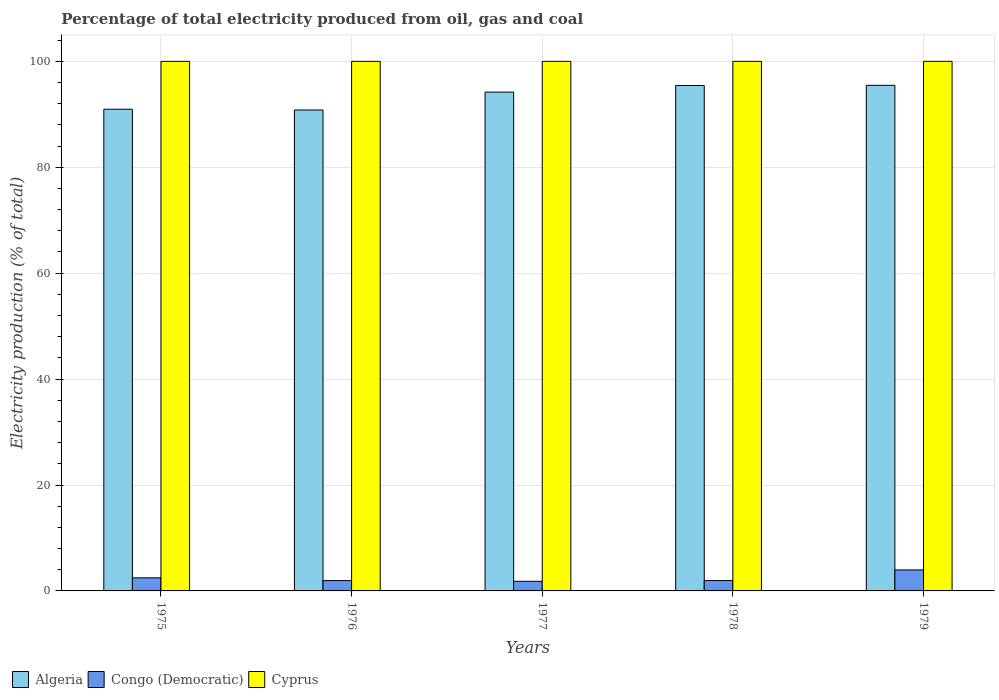How many different coloured bars are there?
Give a very brief answer. 3. How many groups of bars are there?
Provide a short and direct response. 5. Are the number of bars on each tick of the X-axis equal?
Offer a terse response. Yes. How many bars are there on the 1st tick from the right?
Your response must be concise. 3. What is the label of the 2nd group of bars from the left?
Your answer should be compact. 1976. What is the electricity production in in Cyprus in 1976?
Keep it short and to the point. 100. Across all years, what is the maximum electricity production in in Congo (Democratic)?
Provide a short and direct response. 3.97. Across all years, what is the minimum electricity production in in Congo (Democratic)?
Your response must be concise. 1.81. In which year was the electricity production in in Cyprus maximum?
Your response must be concise. 1975. In which year was the electricity production in in Cyprus minimum?
Offer a very short reply. 1975. What is the total electricity production in in Algeria in the graph?
Keep it short and to the point. 466.89. What is the difference between the electricity production in in Congo (Democratic) in 1976 and that in 1978?
Provide a short and direct response. -0. What is the difference between the electricity production in in Congo (Democratic) in 1975 and the electricity production in in Cyprus in 1979?
Offer a terse response. -97.53. What is the average electricity production in in Algeria per year?
Ensure brevity in your answer.  93.38. In the year 1976, what is the difference between the electricity production in in Cyprus and electricity production in in Congo (Democratic)?
Your answer should be compact. 98.04. What is the ratio of the electricity production in in Algeria in 1978 to that in 1979?
Your response must be concise. 1. What is the difference between the highest and the second highest electricity production in in Congo (Democratic)?
Ensure brevity in your answer.  1.49. What is the difference between the highest and the lowest electricity production in in Algeria?
Give a very brief answer. 4.66. Is the sum of the electricity production in in Cyprus in 1975 and 1977 greater than the maximum electricity production in in Algeria across all years?
Your response must be concise. Yes. What does the 3rd bar from the left in 1978 represents?
Ensure brevity in your answer.  Cyprus. What does the 3rd bar from the right in 1976 represents?
Keep it short and to the point. Algeria. Is it the case that in every year, the sum of the electricity production in in Cyprus and electricity production in in Congo (Democratic) is greater than the electricity production in in Algeria?
Your answer should be very brief. Yes. How many bars are there?
Your answer should be compact. 15. Are all the bars in the graph horizontal?
Give a very brief answer. No. Does the graph contain any zero values?
Your answer should be compact. No. Does the graph contain grids?
Provide a short and direct response. Yes. Where does the legend appear in the graph?
Your answer should be compact. Bottom left. How many legend labels are there?
Keep it short and to the point. 3. How are the legend labels stacked?
Offer a very short reply. Horizontal. What is the title of the graph?
Keep it short and to the point. Percentage of total electricity produced from oil, gas and coal. Does "Norway" appear as one of the legend labels in the graph?
Keep it short and to the point. No. What is the label or title of the Y-axis?
Offer a very short reply. Electricity production (% of total). What is the Electricity production (% of total) in Algeria in 1975?
Your answer should be very brief. 90.96. What is the Electricity production (% of total) of Congo (Democratic) in 1975?
Provide a short and direct response. 2.47. What is the Electricity production (% of total) in Cyprus in 1975?
Keep it short and to the point. 100. What is the Electricity production (% of total) of Algeria in 1976?
Ensure brevity in your answer.  90.81. What is the Electricity production (% of total) of Congo (Democratic) in 1976?
Offer a very short reply. 1.96. What is the Electricity production (% of total) of Algeria in 1977?
Your answer should be compact. 94.2. What is the Electricity production (% of total) of Congo (Democratic) in 1977?
Provide a succinct answer. 1.81. What is the Electricity production (% of total) of Algeria in 1978?
Give a very brief answer. 95.44. What is the Electricity production (% of total) in Congo (Democratic) in 1978?
Provide a succinct answer. 1.96. What is the Electricity production (% of total) of Algeria in 1979?
Provide a short and direct response. 95.47. What is the Electricity production (% of total) of Congo (Democratic) in 1979?
Ensure brevity in your answer.  3.97. What is the Electricity production (% of total) in Cyprus in 1979?
Your answer should be compact. 100. Across all years, what is the maximum Electricity production (% of total) of Algeria?
Provide a short and direct response. 95.47. Across all years, what is the maximum Electricity production (% of total) in Congo (Democratic)?
Provide a short and direct response. 3.97. Across all years, what is the maximum Electricity production (% of total) in Cyprus?
Keep it short and to the point. 100. Across all years, what is the minimum Electricity production (% of total) of Algeria?
Give a very brief answer. 90.81. Across all years, what is the minimum Electricity production (% of total) of Congo (Democratic)?
Provide a succinct answer. 1.81. Across all years, what is the minimum Electricity production (% of total) of Cyprus?
Offer a terse response. 100. What is the total Electricity production (% of total) in Algeria in the graph?
Offer a very short reply. 466.89. What is the total Electricity production (% of total) of Congo (Democratic) in the graph?
Your response must be concise. 12.17. What is the total Electricity production (% of total) in Cyprus in the graph?
Your response must be concise. 500. What is the difference between the Electricity production (% of total) of Algeria in 1975 and that in 1976?
Ensure brevity in your answer.  0.15. What is the difference between the Electricity production (% of total) in Congo (Democratic) in 1975 and that in 1976?
Give a very brief answer. 0.52. What is the difference between the Electricity production (% of total) in Algeria in 1975 and that in 1977?
Give a very brief answer. -3.23. What is the difference between the Electricity production (% of total) of Congo (Democratic) in 1975 and that in 1977?
Your answer should be very brief. 0.66. What is the difference between the Electricity production (% of total) of Algeria in 1975 and that in 1978?
Provide a succinct answer. -4.47. What is the difference between the Electricity production (% of total) of Congo (Democratic) in 1975 and that in 1978?
Provide a short and direct response. 0.51. What is the difference between the Electricity production (% of total) in Algeria in 1975 and that in 1979?
Offer a terse response. -4.51. What is the difference between the Electricity production (% of total) of Congo (Democratic) in 1975 and that in 1979?
Offer a very short reply. -1.49. What is the difference between the Electricity production (% of total) of Cyprus in 1975 and that in 1979?
Your answer should be compact. 0. What is the difference between the Electricity production (% of total) in Algeria in 1976 and that in 1977?
Your response must be concise. -3.38. What is the difference between the Electricity production (% of total) in Congo (Democratic) in 1976 and that in 1977?
Your answer should be compact. 0.15. What is the difference between the Electricity production (% of total) in Cyprus in 1976 and that in 1977?
Make the answer very short. 0. What is the difference between the Electricity production (% of total) of Algeria in 1976 and that in 1978?
Give a very brief answer. -4.62. What is the difference between the Electricity production (% of total) in Congo (Democratic) in 1976 and that in 1978?
Your answer should be very brief. -0. What is the difference between the Electricity production (% of total) of Cyprus in 1976 and that in 1978?
Make the answer very short. 0. What is the difference between the Electricity production (% of total) of Algeria in 1976 and that in 1979?
Ensure brevity in your answer.  -4.66. What is the difference between the Electricity production (% of total) in Congo (Democratic) in 1976 and that in 1979?
Keep it short and to the point. -2.01. What is the difference between the Electricity production (% of total) of Algeria in 1977 and that in 1978?
Offer a terse response. -1.24. What is the difference between the Electricity production (% of total) of Congo (Democratic) in 1977 and that in 1978?
Your response must be concise. -0.15. What is the difference between the Electricity production (% of total) in Cyprus in 1977 and that in 1978?
Provide a short and direct response. 0. What is the difference between the Electricity production (% of total) of Algeria in 1977 and that in 1979?
Your answer should be compact. -1.28. What is the difference between the Electricity production (% of total) of Congo (Democratic) in 1977 and that in 1979?
Ensure brevity in your answer.  -2.16. What is the difference between the Electricity production (% of total) in Algeria in 1978 and that in 1979?
Ensure brevity in your answer.  -0.04. What is the difference between the Electricity production (% of total) of Congo (Democratic) in 1978 and that in 1979?
Provide a short and direct response. -2.01. What is the difference between the Electricity production (% of total) in Algeria in 1975 and the Electricity production (% of total) in Congo (Democratic) in 1976?
Offer a very short reply. 89.01. What is the difference between the Electricity production (% of total) in Algeria in 1975 and the Electricity production (% of total) in Cyprus in 1976?
Keep it short and to the point. -9.04. What is the difference between the Electricity production (% of total) of Congo (Democratic) in 1975 and the Electricity production (% of total) of Cyprus in 1976?
Offer a terse response. -97.53. What is the difference between the Electricity production (% of total) of Algeria in 1975 and the Electricity production (% of total) of Congo (Democratic) in 1977?
Keep it short and to the point. 89.15. What is the difference between the Electricity production (% of total) in Algeria in 1975 and the Electricity production (% of total) in Cyprus in 1977?
Offer a very short reply. -9.04. What is the difference between the Electricity production (% of total) in Congo (Democratic) in 1975 and the Electricity production (% of total) in Cyprus in 1977?
Your response must be concise. -97.53. What is the difference between the Electricity production (% of total) of Algeria in 1975 and the Electricity production (% of total) of Congo (Democratic) in 1978?
Offer a terse response. 89. What is the difference between the Electricity production (% of total) of Algeria in 1975 and the Electricity production (% of total) of Cyprus in 1978?
Offer a terse response. -9.04. What is the difference between the Electricity production (% of total) of Congo (Democratic) in 1975 and the Electricity production (% of total) of Cyprus in 1978?
Keep it short and to the point. -97.53. What is the difference between the Electricity production (% of total) in Algeria in 1975 and the Electricity production (% of total) in Congo (Democratic) in 1979?
Keep it short and to the point. 87. What is the difference between the Electricity production (% of total) of Algeria in 1975 and the Electricity production (% of total) of Cyprus in 1979?
Keep it short and to the point. -9.04. What is the difference between the Electricity production (% of total) in Congo (Democratic) in 1975 and the Electricity production (% of total) in Cyprus in 1979?
Your answer should be very brief. -97.53. What is the difference between the Electricity production (% of total) of Algeria in 1976 and the Electricity production (% of total) of Congo (Democratic) in 1977?
Provide a succinct answer. 89. What is the difference between the Electricity production (% of total) in Algeria in 1976 and the Electricity production (% of total) in Cyprus in 1977?
Offer a terse response. -9.19. What is the difference between the Electricity production (% of total) in Congo (Democratic) in 1976 and the Electricity production (% of total) in Cyprus in 1977?
Offer a terse response. -98.04. What is the difference between the Electricity production (% of total) of Algeria in 1976 and the Electricity production (% of total) of Congo (Democratic) in 1978?
Ensure brevity in your answer.  88.85. What is the difference between the Electricity production (% of total) in Algeria in 1976 and the Electricity production (% of total) in Cyprus in 1978?
Make the answer very short. -9.19. What is the difference between the Electricity production (% of total) of Congo (Democratic) in 1976 and the Electricity production (% of total) of Cyprus in 1978?
Offer a very short reply. -98.04. What is the difference between the Electricity production (% of total) in Algeria in 1976 and the Electricity production (% of total) in Congo (Democratic) in 1979?
Ensure brevity in your answer.  86.85. What is the difference between the Electricity production (% of total) in Algeria in 1976 and the Electricity production (% of total) in Cyprus in 1979?
Make the answer very short. -9.19. What is the difference between the Electricity production (% of total) of Congo (Democratic) in 1976 and the Electricity production (% of total) of Cyprus in 1979?
Provide a succinct answer. -98.04. What is the difference between the Electricity production (% of total) of Algeria in 1977 and the Electricity production (% of total) of Congo (Democratic) in 1978?
Keep it short and to the point. 92.24. What is the difference between the Electricity production (% of total) in Algeria in 1977 and the Electricity production (% of total) in Cyprus in 1978?
Your answer should be very brief. -5.8. What is the difference between the Electricity production (% of total) in Congo (Democratic) in 1977 and the Electricity production (% of total) in Cyprus in 1978?
Provide a short and direct response. -98.19. What is the difference between the Electricity production (% of total) of Algeria in 1977 and the Electricity production (% of total) of Congo (Democratic) in 1979?
Offer a terse response. 90.23. What is the difference between the Electricity production (% of total) in Algeria in 1977 and the Electricity production (% of total) in Cyprus in 1979?
Provide a short and direct response. -5.8. What is the difference between the Electricity production (% of total) of Congo (Democratic) in 1977 and the Electricity production (% of total) of Cyprus in 1979?
Provide a succinct answer. -98.19. What is the difference between the Electricity production (% of total) in Algeria in 1978 and the Electricity production (% of total) in Congo (Democratic) in 1979?
Provide a short and direct response. 91.47. What is the difference between the Electricity production (% of total) of Algeria in 1978 and the Electricity production (% of total) of Cyprus in 1979?
Your answer should be very brief. -4.56. What is the difference between the Electricity production (% of total) in Congo (Democratic) in 1978 and the Electricity production (% of total) in Cyprus in 1979?
Your answer should be very brief. -98.04. What is the average Electricity production (% of total) of Algeria per year?
Your answer should be very brief. 93.38. What is the average Electricity production (% of total) in Congo (Democratic) per year?
Give a very brief answer. 2.43. What is the average Electricity production (% of total) in Cyprus per year?
Your response must be concise. 100. In the year 1975, what is the difference between the Electricity production (% of total) in Algeria and Electricity production (% of total) in Congo (Democratic)?
Make the answer very short. 88.49. In the year 1975, what is the difference between the Electricity production (% of total) in Algeria and Electricity production (% of total) in Cyprus?
Provide a succinct answer. -9.04. In the year 1975, what is the difference between the Electricity production (% of total) of Congo (Democratic) and Electricity production (% of total) of Cyprus?
Your answer should be compact. -97.53. In the year 1976, what is the difference between the Electricity production (% of total) in Algeria and Electricity production (% of total) in Congo (Democratic)?
Offer a terse response. 88.86. In the year 1976, what is the difference between the Electricity production (% of total) of Algeria and Electricity production (% of total) of Cyprus?
Provide a succinct answer. -9.19. In the year 1976, what is the difference between the Electricity production (% of total) in Congo (Democratic) and Electricity production (% of total) in Cyprus?
Provide a succinct answer. -98.04. In the year 1977, what is the difference between the Electricity production (% of total) in Algeria and Electricity production (% of total) in Congo (Democratic)?
Your answer should be compact. 92.39. In the year 1977, what is the difference between the Electricity production (% of total) of Algeria and Electricity production (% of total) of Cyprus?
Keep it short and to the point. -5.8. In the year 1977, what is the difference between the Electricity production (% of total) in Congo (Democratic) and Electricity production (% of total) in Cyprus?
Offer a terse response. -98.19. In the year 1978, what is the difference between the Electricity production (% of total) in Algeria and Electricity production (% of total) in Congo (Democratic)?
Your response must be concise. 93.48. In the year 1978, what is the difference between the Electricity production (% of total) of Algeria and Electricity production (% of total) of Cyprus?
Your answer should be very brief. -4.56. In the year 1978, what is the difference between the Electricity production (% of total) in Congo (Democratic) and Electricity production (% of total) in Cyprus?
Offer a terse response. -98.04. In the year 1979, what is the difference between the Electricity production (% of total) in Algeria and Electricity production (% of total) in Congo (Democratic)?
Give a very brief answer. 91.51. In the year 1979, what is the difference between the Electricity production (% of total) in Algeria and Electricity production (% of total) in Cyprus?
Make the answer very short. -4.53. In the year 1979, what is the difference between the Electricity production (% of total) in Congo (Democratic) and Electricity production (% of total) in Cyprus?
Give a very brief answer. -96.03. What is the ratio of the Electricity production (% of total) in Congo (Democratic) in 1975 to that in 1976?
Offer a very short reply. 1.26. What is the ratio of the Electricity production (% of total) in Algeria in 1975 to that in 1977?
Provide a short and direct response. 0.97. What is the ratio of the Electricity production (% of total) in Congo (Democratic) in 1975 to that in 1977?
Offer a terse response. 1.37. What is the ratio of the Electricity production (% of total) of Cyprus in 1975 to that in 1977?
Provide a short and direct response. 1. What is the ratio of the Electricity production (% of total) in Algeria in 1975 to that in 1978?
Provide a succinct answer. 0.95. What is the ratio of the Electricity production (% of total) of Congo (Democratic) in 1975 to that in 1978?
Your answer should be compact. 1.26. What is the ratio of the Electricity production (% of total) in Cyprus in 1975 to that in 1978?
Give a very brief answer. 1. What is the ratio of the Electricity production (% of total) of Algeria in 1975 to that in 1979?
Ensure brevity in your answer.  0.95. What is the ratio of the Electricity production (% of total) in Congo (Democratic) in 1975 to that in 1979?
Ensure brevity in your answer.  0.62. What is the ratio of the Electricity production (% of total) of Algeria in 1976 to that in 1977?
Keep it short and to the point. 0.96. What is the ratio of the Electricity production (% of total) of Congo (Democratic) in 1976 to that in 1977?
Provide a succinct answer. 1.08. What is the ratio of the Electricity production (% of total) in Algeria in 1976 to that in 1978?
Your response must be concise. 0.95. What is the ratio of the Electricity production (% of total) of Congo (Democratic) in 1976 to that in 1978?
Keep it short and to the point. 1. What is the ratio of the Electricity production (% of total) in Algeria in 1976 to that in 1979?
Offer a very short reply. 0.95. What is the ratio of the Electricity production (% of total) in Congo (Democratic) in 1976 to that in 1979?
Your response must be concise. 0.49. What is the ratio of the Electricity production (% of total) in Congo (Democratic) in 1977 to that in 1978?
Offer a terse response. 0.92. What is the ratio of the Electricity production (% of total) in Algeria in 1977 to that in 1979?
Your answer should be very brief. 0.99. What is the ratio of the Electricity production (% of total) in Congo (Democratic) in 1977 to that in 1979?
Your answer should be compact. 0.46. What is the ratio of the Electricity production (% of total) in Algeria in 1978 to that in 1979?
Your answer should be very brief. 1. What is the ratio of the Electricity production (% of total) in Congo (Democratic) in 1978 to that in 1979?
Your answer should be compact. 0.49. What is the ratio of the Electricity production (% of total) in Cyprus in 1978 to that in 1979?
Make the answer very short. 1. What is the difference between the highest and the second highest Electricity production (% of total) of Algeria?
Give a very brief answer. 0.04. What is the difference between the highest and the second highest Electricity production (% of total) in Congo (Democratic)?
Your response must be concise. 1.49. What is the difference between the highest and the lowest Electricity production (% of total) in Algeria?
Your response must be concise. 4.66. What is the difference between the highest and the lowest Electricity production (% of total) of Congo (Democratic)?
Offer a terse response. 2.16. 